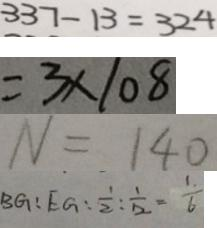Convert formula to latex. <formula><loc_0><loc_0><loc_500><loc_500>3 3 7 - 1 3 = 3 2 4 
 = 3 \times 1 0 8 
 N = 1 4 0 
 B G : E G : \frac { 1 } { 2 } : \frac { 1 } { 1 2 } = \frac { 1 } { 6 }</formula> 